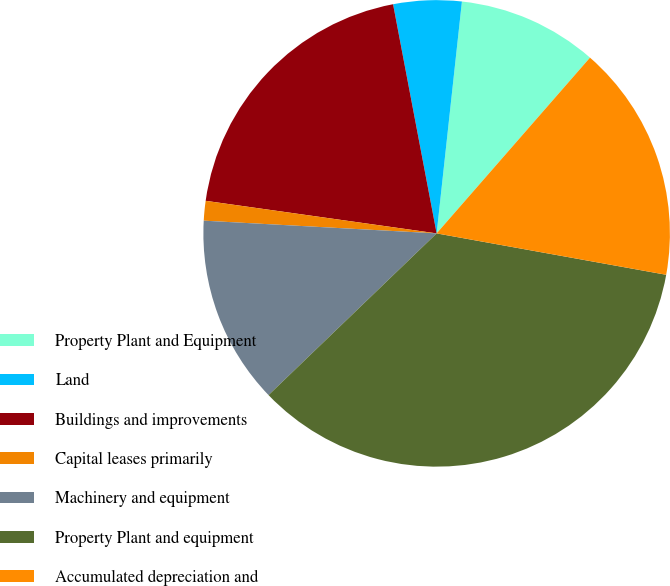<chart> <loc_0><loc_0><loc_500><loc_500><pie_chart><fcel>Property Plant and Equipment<fcel>Land<fcel>Buildings and improvements<fcel>Capital leases primarily<fcel>Machinery and equipment<fcel>Property Plant and equipment<fcel>Accumulated depreciation and<nl><fcel>9.69%<fcel>4.72%<fcel>19.78%<fcel>1.36%<fcel>13.06%<fcel>34.97%<fcel>16.42%<nl></chart> 